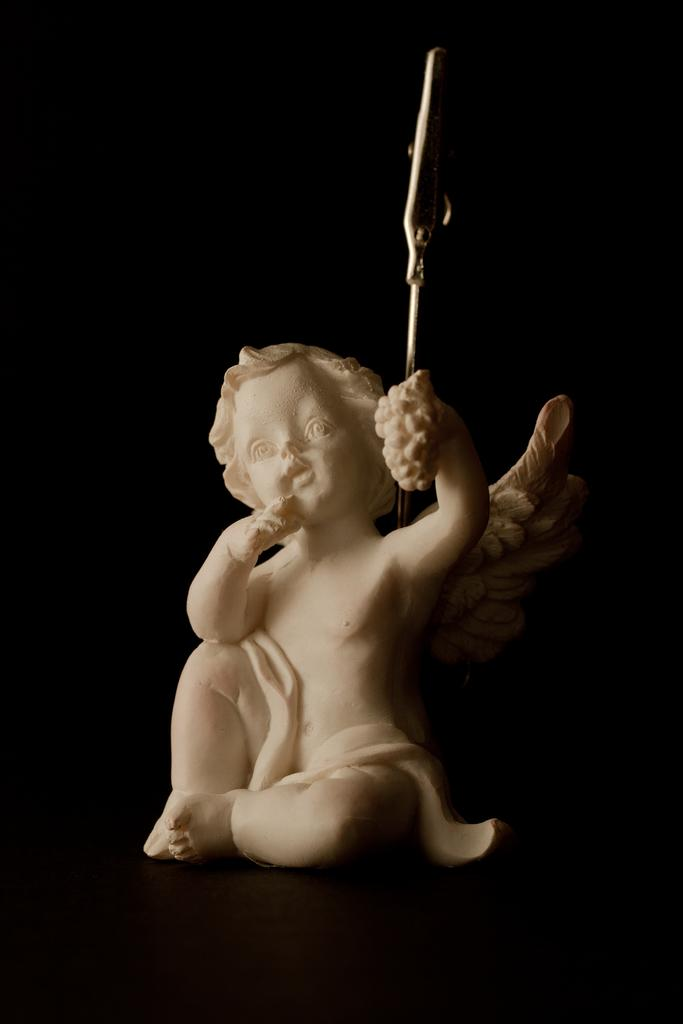What is the main subject of the image? There is a sculpture in the center of the image. What type of bells can be heard ringing in the image? There are no bells present in the image, and therefore no sounds can be heard. What type of vest is the sculpture wearing in the image? The sculpture is not wearing a vest, as it is an inanimate object. 